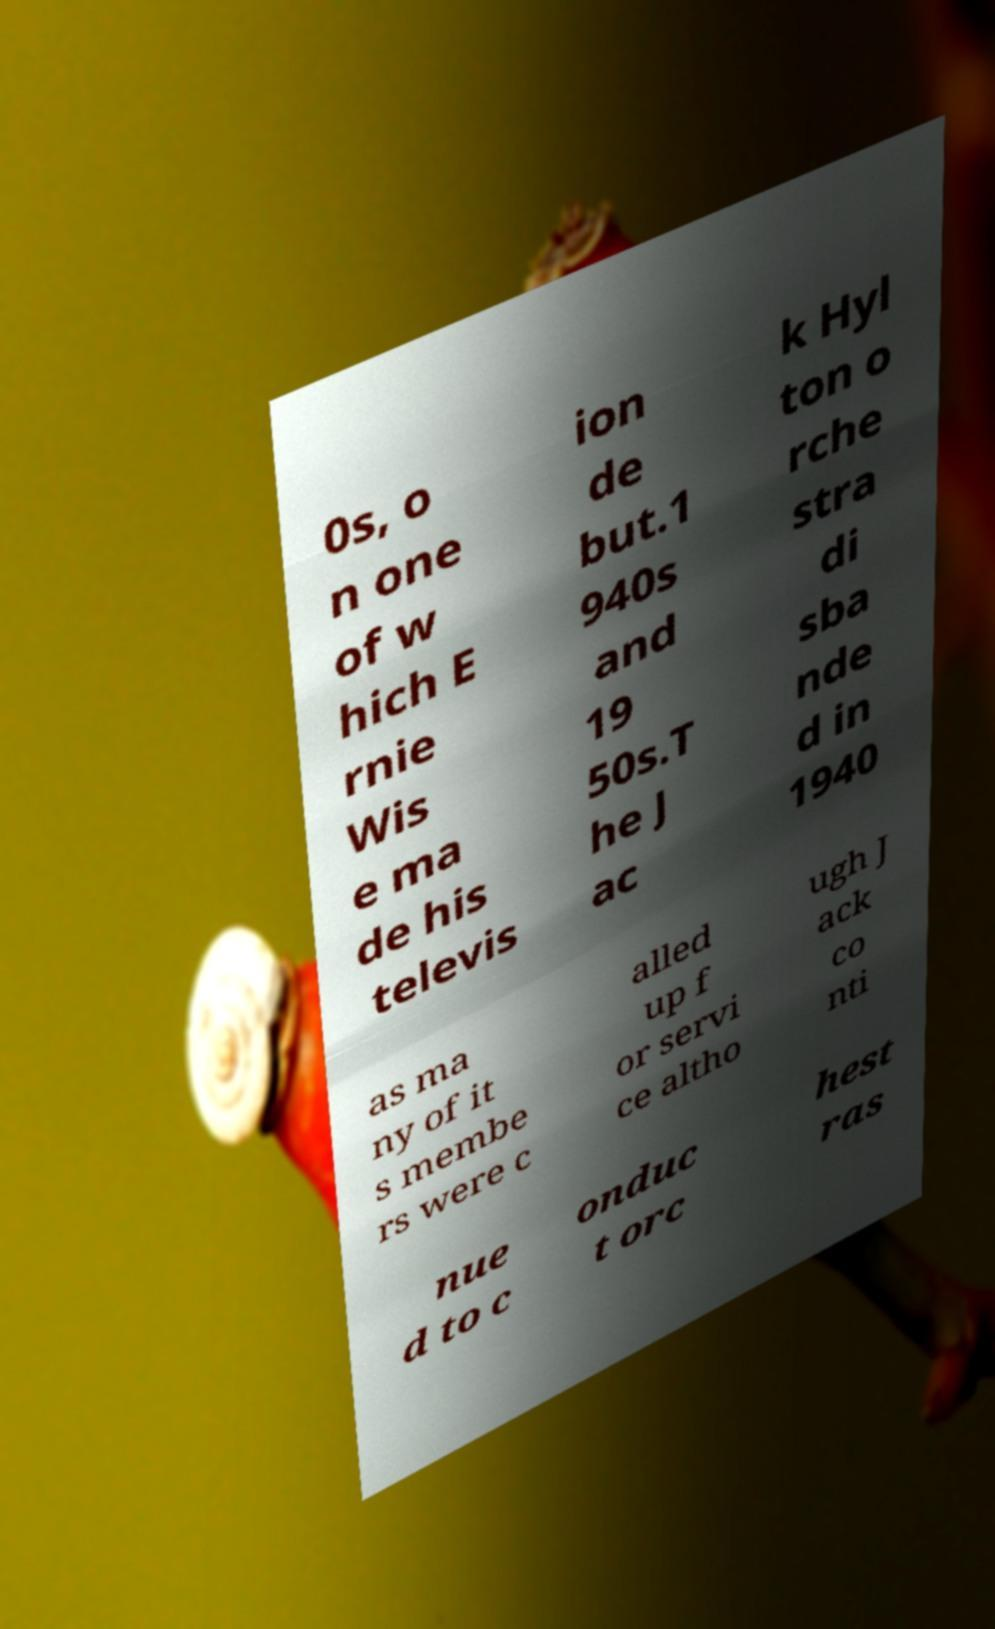Please read and relay the text visible in this image. What does it say? 0s, o n one of w hich E rnie Wis e ma de his televis ion de but.1 940s and 19 50s.T he J ac k Hyl ton o rche stra di sba nde d in 1940 as ma ny of it s membe rs were c alled up f or servi ce altho ugh J ack co nti nue d to c onduc t orc hest ras 